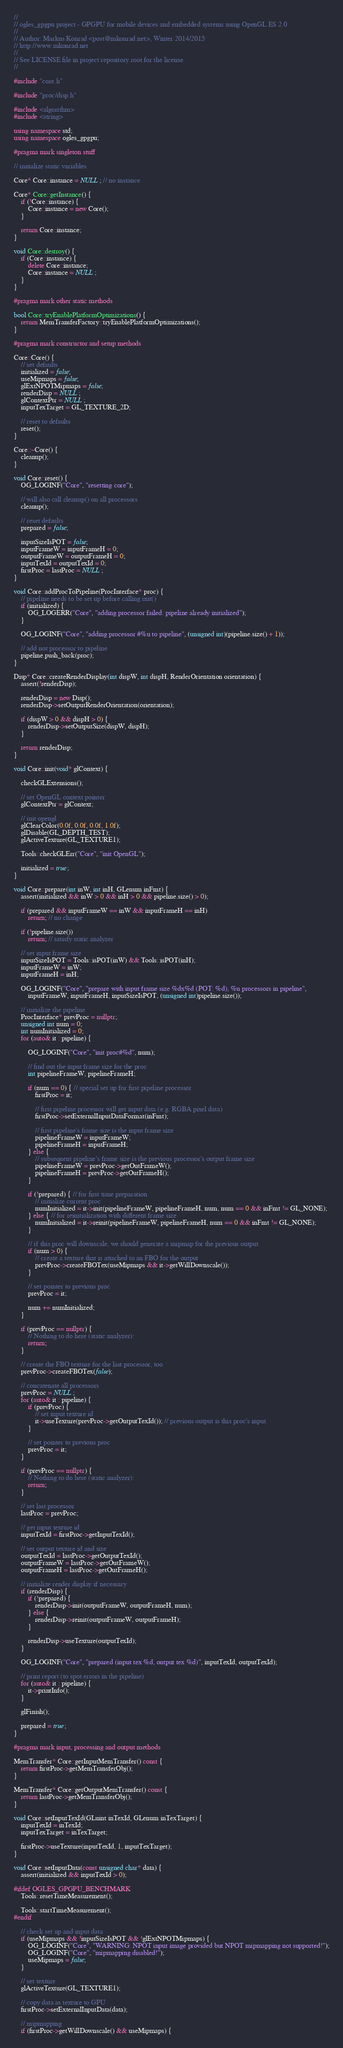<code> <loc_0><loc_0><loc_500><loc_500><_C++_>//
// ogles_gpgpu project - GPGPU for mobile devices and embedded systems using OpenGL ES 2.0
//
// Author: Markus Konrad <post@mkonrad.net>, Winter 2014/2015
// http://www.mkonrad.net
//
// See LICENSE file in project repository root for the license.
//

#include "core.h"

#include "proc/disp.h"

#include <algorithm>
#include <string>

using namespace std;
using namespace ogles_gpgpu;

#pragma mark singleton stuff

// initialize static variables

Core* Core::instance = NULL; // no instance

Core* Core::getInstance() {
    if (!Core::instance) {
        Core::instance = new Core();
    }

    return Core::instance;
}

void Core::destroy() {
    if (Core::instance) {
        delete Core::instance;
        Core::instance = NULL;
    }
}

#pragma mark other static methods

bool Core::tryEnablePlatformOptimizations() {
    return MemTransferFactory::tryEnablePlatformOptimizations();
}

#pragma mark constructor and setup methods

Core::Core() {
    // set defaults
    initialized = false;
    useMipmaps = false;
    glExtNPOTMipmaps = false;
    renderDisp = NULL;
    glContextPtr = NULL;
    inputTexTarget = GL_TEXTURE_2D;

    // reset to defaults
    reset();
}

Core::~Core() {
    cleanup();
}

void Core::reset() {
    OG_LOGINF("Core", "resetting core");

    // will also call cleanup() on all processors
    cleanup();

    // reset defaults
    prepared = false;

    inputSizeIsPOT = false;
    inputFrameW = inputFrameH = 0;
    outputFrameW = outputFrameH = 0;
    inputTexId = outputTexId = 0;
    firstProc = lastProc = NULL;
}

void Core::addProcToPipeline(ProcInterface* proc) {
    // pipeline needs to be set up before calling init()
    if (initialized) {
        OG_LOGERR("Core", "adding processor failed: pipeline already initialized");
    }

    OG_LOGINF("Core", "adding processor #%u to pipeline", (unsigned int)(pipeline.size() + 1));

    // add not processor to pipeline
    pipeline.push_back(proc);
}

Disp* Core::createRenderDisplay(int dispW, int dispH, RenderOrientation orientation) {
    assert(!renderDisp);

    renderDisp = new Disp();
    renderDisp->setOutputRenderOrientation(orientation);

    if (dispW > 0 && dispH > 0) {
        renderDisp->setOutputSize(dispW, dispH);
    }

    return renderDisp;
}

void Core::init(void* glContext) {

    checkGLExtensions();

    // set OpenGL context pointer
    glContextPtr = glContext;

    // init opengl
    glClearColor(0.0f, 0.0f, 0.0f, 1.0f);
    glDisable(GL_DEPTH_TEST);
    glActiveTexture(GL_TEXTURE1);

    Tools::checkGLErr("Core", "init OpenGL");

    initialized = true;
}

void Core::prepare(int inW, int inH, GLenum inFmt) {
    assert(initialized && inW > 0 && inH > 0 && pipeline.size() > 0);

    if (prepared && inputFrameW == inW && inputFrameH == inH)
        return; // no change

    if (!pipeline.size())
        return; // satisfy static analyzer

    // set input frame size
    inputSizeIsPOT = Tools::isPOT(inW) && Tools::isPOT(inH);
    inputFrameW = inW;
    inputFrameH = inH;

    OG_LOGINF("Core", "prepare with input frame size %dx%d (POT: %d), %u processors in pipeline",
        inputFrameW, inputFrameH, inputSizeIsPOT, (unsigned int)pipeline.size());

    // initialize the pipeline
    ProcInterface* prevProc = nullptr;
    unsigned int num = 0;
    int numInitialized = 0;
    for (auto& it : pipeline) {

        OG_LOGINF("Core", "init proc#%d", num);

        // find out the input frame size for the proc
        int pipelineFrameW, pipelineFrameH;

        if (num == 0) { // special set up for first pipeline processor
            firstProc = it;

            // first pipeline processor will get input data (e.g. RGBA pixel data)
            firstProc->setExternalInputDataFormat(inFmt);

            // first pipeline's frame size is the input frame size
            pipelineFrameW = inputFrameW;
            pipelineFrameH = inputFrameH;
        } else {
            // subsequent pipeline's frame size is the previous processor's output frame size
            pipelineFrameW = prevProc->getOutFrameW();
            pipelineFrameH = prevProc->getOutFrameH();
        }

        if (!prepared) { // for first time preparation
            // initialize current proc
            numInitialized = it->init(pipelineFrameW, pipelineFrameH, num, num == 0 && inFmt != GL_NONE);
        } else { // for reinitialization with different frame size
            numInitialized = it->reinit(pipelineFrameW, pipelineFrameH, num == 0 && inFmt != GL_NONE);
        }

        // if this proc will downscale, we should generate a mipmap for the previous output
        if (num > 0) {
            // create a texture that is attached to an FBO for the output
            prevProc->createFBOTex(useMipmaps && it->getWillDownscale());
        }

        // set pointer to previous proc
        prevProc = it;

        num += numInitialized;
    }

    if (prevProc == nullptr) {
        // Nothing to do here (static analyzer):
        return;
    }

    // create the FBO texture for the last processor, too
    prevProc->createFBOTex(false);

    // concatenate all processors
    prevProc = NULL;
    for (auto& it : pipeline) {
        if (prevProc) {
            // set input texture id
            it->useTexture(prevProc->getOutputTexId()); // previous output is this proc's input
        }

        // set pointer to previous proc
        prevProc = it;
    }

    if (prevProc == nullptr) {
        // Nothing to do here (static analyzer):
        return;
    }

    // set last processor
    lastProc = prevProc;

    // get input texture id
    inputTexId = firstProc->getInputTexId();

    // set output texture id and size
    outputTexId = lastProc->getOutputTexId();
    outputFrameW = lastProc->getOutFrameW();
    outputFrameH = lastProc->getOutFrameH();

    // initialize render display if necessary
    if (renderDisp) {
        if (!prepared) {
            renderDisp->init(outputFrameW, outputFrameH, num);
        } else {
            renderDisp->reinit(outputFrameW, outputFrameH);
        }

        renderDisp->useTexture(outputTexId);
    }

    OG_LOGINF("Core", "prepared (input tex %d, output tex %d)", inputTexId, outputTexId);

    // print report (to spot errors in the pipeline)
    for (auto& it : pipeline) {
        it->printInfo();
    }

    glFinish();

    prepared = true;
}

#pragma mark input, processing and output methods

MemTransfer* Core::getInputMemTransfer() const {
    return firstProc->getMemTransferObj();
}

MemTransfer* Core::getOutputMemTransfer() const {
    return lastProc->getMemTransferObj();
}

void Core::setInputTexId(GLuint inTexId, GLenum inTexTarget) {
    inputTexId = inTexId;
    inputTexTarget = inTexTarget;

    firstProc->useTexture(inputTexId, 1, inputTexTarget);
}

void Core::setInputData(const unsigned char* data) {
    assert(initialized && inputTexId > 0);

#ifdef OGLES_GPGPU_BENCHMARK
    Tools::resetTimeMeasurement();

    Tools::startTimeMeasurement();
#endif

    // check set up and input data
    if (useMipmaps && !inputSizeIsPOT && !glExtNPOTMipmaps) {
        OG_LOGINF("Core", "WARNING: NPOT input image provided but NPOT mipmapping not supported!");
        OG_LOGINF("Core", "mipmapping disabled!");
        useMipmaps = false;
    }

    // set texture
    glActiveTexture(GL_TEXTURE1);

    // copy data as texture to GPU
    firstProc->setExternalInputData(data);

    // mipmapping
    if (firstProc->getWillDownscale() && useMipmaps) {</code> 